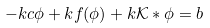<formula> <loc_0><loc_0><loc_500><loc_500>- k c \phi + k f ( \phi ) + k \mathcal { K } * \phi = b</formula> 